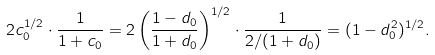Convert formula to latex. <formula><loc_0><loc_0><loc_500><loc_500>2 c _ { 0 } ^ { 1 / 2 } \cdot \frac { 1 } { 1 + c _ { 0 } } = 2 \left ( \frac { 1 - d _ { 0 } } { 1 + d _ { 0 } } \right ) ^ { 1 / 2 } \cdot \frac { 1 } { 2 / ( 1 + d _ { 0 } ) } = ( 1 - d _ { 0 } ^ { 2 } ) ^ { 1 / 2 } .</formula> 